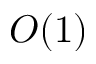<formula> <loc_0><loc_0><loc_500><loc_500>O ( 1 )</formula> 